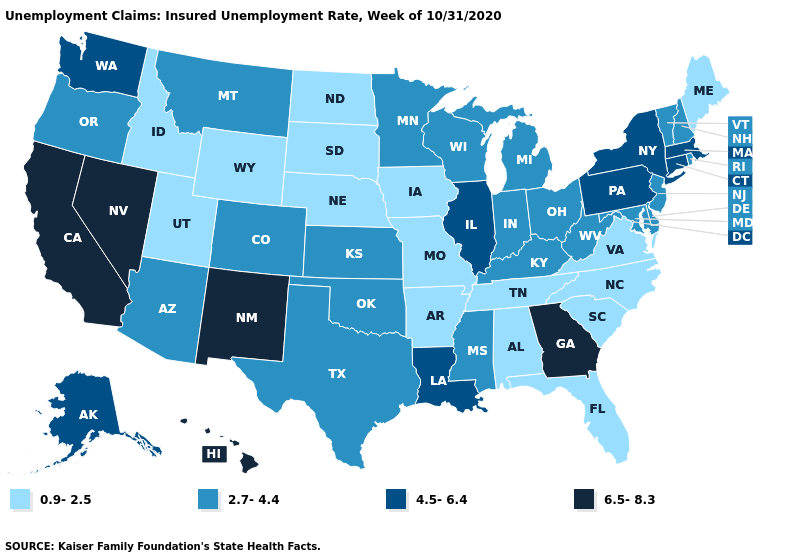What is the lowest value in the USA?
Short answer required. 0.9-2.5. Does Georgia have the highest value in the USA?
Be succinct. Yes. Does the map have missing data?
Give a very brief answer. No. Does the first symbol in the legend represent the smallest category?
Write a very short answer. Yes. Does Minnesota have a lower value than Idaho?
Give a very brief answer. No. What is the lowest value in the USA?
Concise answer only. 0.9-2.5. Among the states that border South Carolina , which have the highest value?
Concise answer only. Georgia. Is the legend a continuous bar?
Short answer required. No. What is the value of Washington?
Keep it brief. 4.5-6.4. Does Maryland have the same value as Arkansas?
Write a very short answer. No. What is the highest value in states that border Oklahoma?
Concise answer only. 6.5-8.3. Name the states that have a value in the range 6.5-8.3?
Answer briefly. California, Georgia, Hawaii, Nevada, New Mexico. Among the states that border New Mexico , which have the highest value?
Give a very brief answer. Arizona, Colorado, Oklahoma, Texas. What is the value of Idaho?
Concise answer only. 0.9-2.5. 